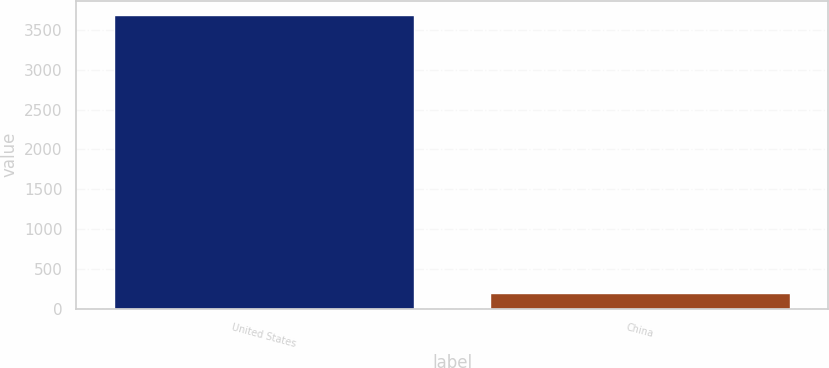Convert chart. <chart><loc_0><loc_0><loc_500><loc_500><bar_chart><fcel>United States<fcel>China<nl><fcel>3685<fcel>198<nl></chart> 